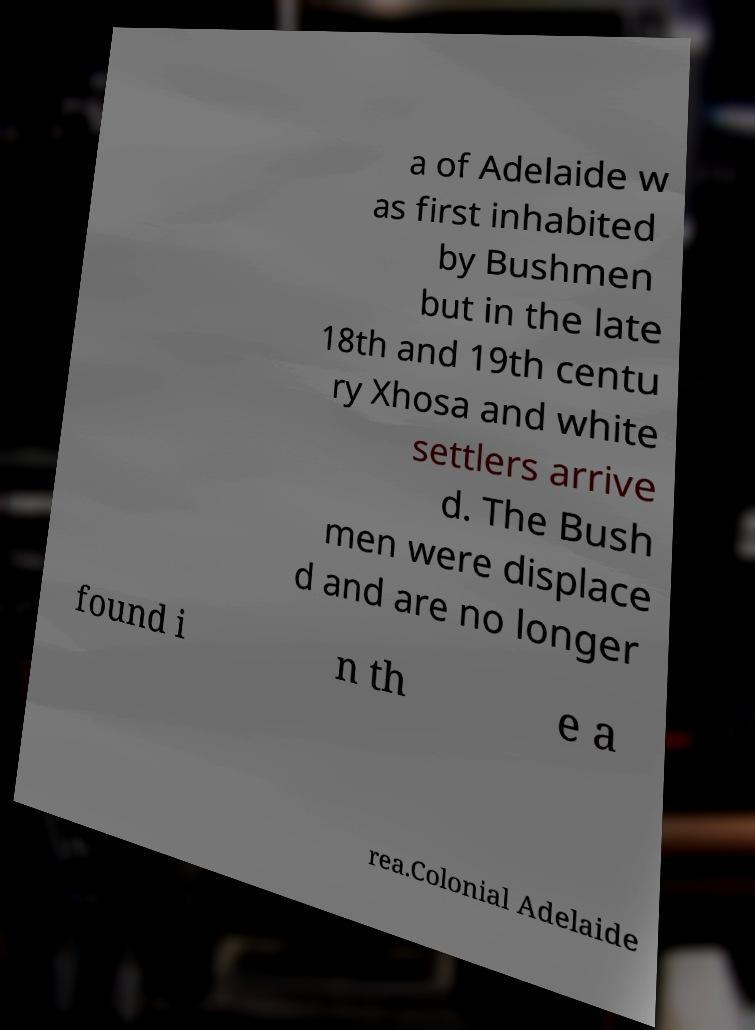I need the written content from this picture converted into text. Can you do that? a of Adelaide w as first inhabited by Bushmen but in the late 18th and 19th centu ry Xhosa and white settlers arrive d. The Bush men were displace d and are no longer found i n th e a rea.Colonial Adelaide 